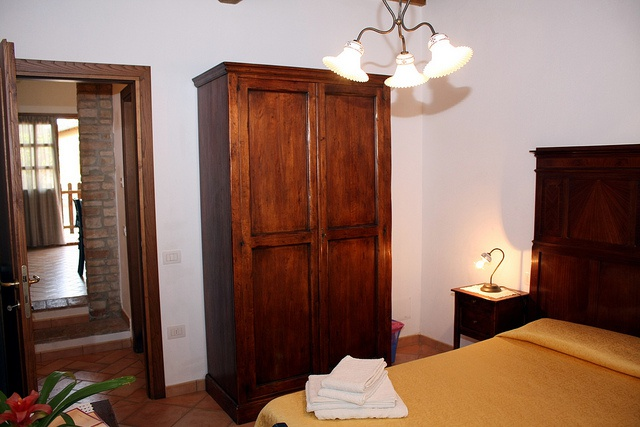Describe the objects in this image and their specific colors. I can see bed in darkgray, black, red, and orange tones and potted plant in darkgray, black, maroon, darkgreen, and gray tones in this image. 